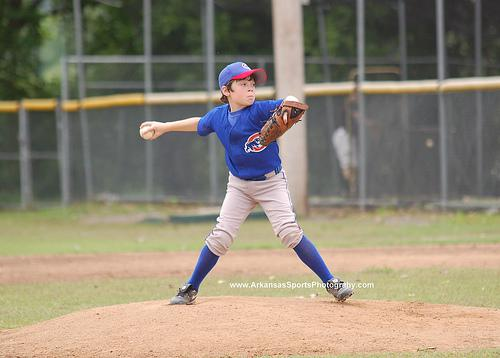Question: what sport is being played?
Choices:
A. Jai Alai.
B. Badmitten.
C. Baseball.
D. Wrestling.
Answer with the letter. Answer: C Question: what is in the boy's left hand?
Choices:
A. Glove.
B. Ball.
C. Rag.
D. Wii remote.
Answer with the letter. Answer: A Question: where was this taken?
Choices:
A. Baseball field.
B. Park.
C. Field.
D. Backyard.
Answer with the letter. Answer: A Question: what is in the boy's right hand?
Choices:
A. Stick.
B. Rock.
C. Balloon.
D. Ball.
Answer with the letter. Answer: D Question: what is on the boy's head?
Choices:
A. Hair.
B. Hat.
C. Bandana.
D. Glasses.
Answer with the letter. Answer: B Question: what position is the boy playing?
Choices:
A. Pitcher.
B. Goalie.
C. Catcher.
D. Center.
Answer with the letter. Answer: A 